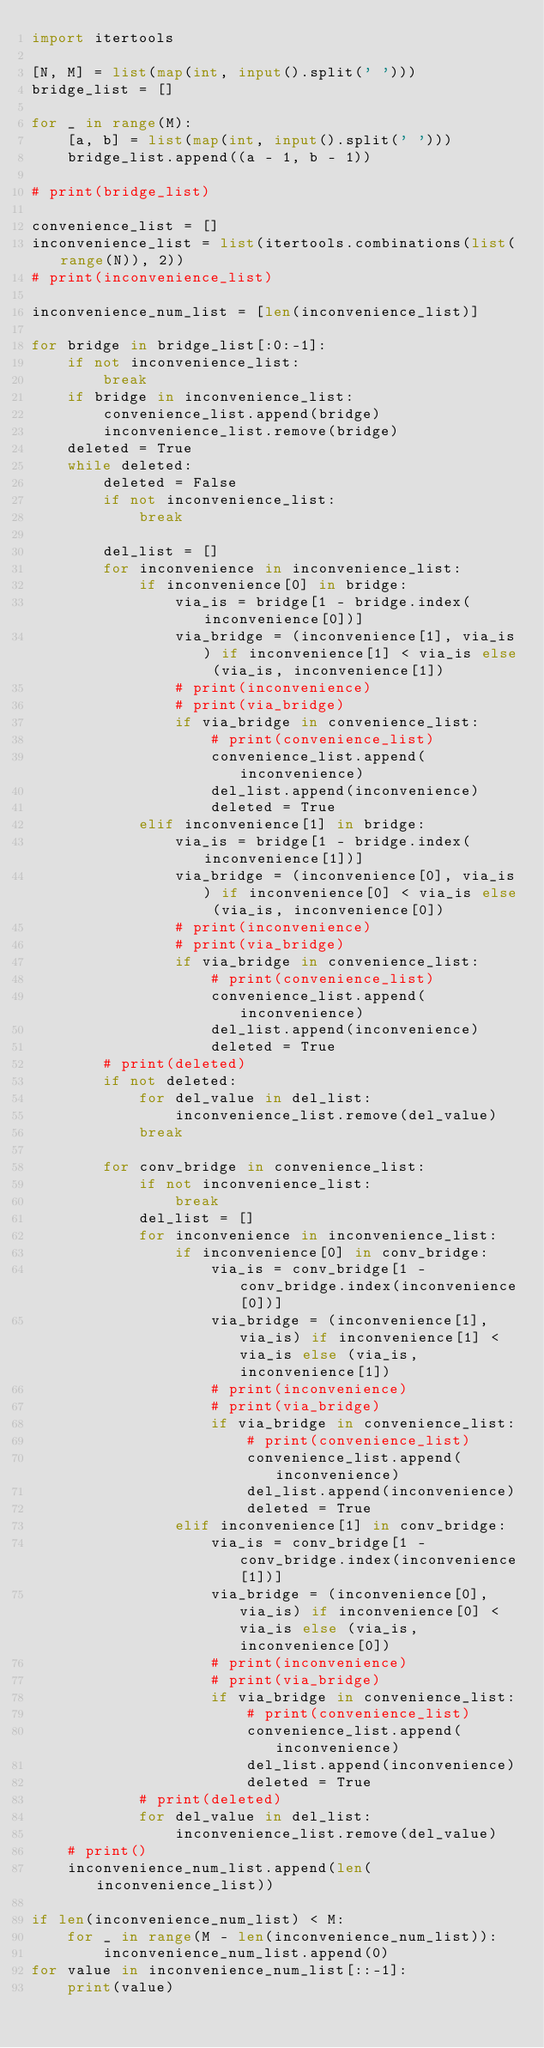<code> <loc_0><loc_0><loc_500><loc_500><_Python_>import itertools

[N, M] = list(map(int, input().split(' ')))
bridge_list = []

for _ in range(M):
    [a, b] = list(map(int, input().split(' ')))
    bridge_list.append((a - 1, b - 1))

# print(bridge_list)

convenience_list = []
inconvenience_list = list(itertools.combinations(list(range(N)), 2))
# print(inconvenience_list)

inconvenience_num_list = [len(inconvenience_list)]

for bridge in bridge_list[:0:-1]:
    if not inconvenience_list:
        break
    if bridge in inconvenience_list:
        convenience_list.append(bridge)
        inconvenience_list.remove(bridge)
    deleted = True
    while deleted:
        deleted = False
        if not inconvenience_list:
            break

        del_list = []
        for inconvenience in inconvenience_list:
            if inconvenience[0] in bridge:
                via_is = bridge[1 - bridge.index(inconvenience[0])]
                via_bridge = (inconvenience[1], via_is) if inconvenience[1] < via_is else (via_is, inconvenience[1])
                # print(inconvenience)
                # print(via_bridge)
                if via_bridge in convenience_list:
                    # print(convenience_list)
                    convenience_list.append(inconvenience)
                    del_list.append(inconvenience)
                    deleted = True
            elif inconvenience[1] in bridge:
                via_is = bridge[1 - bridge.index(inconvenience[1])]
                via_bridge = (inconvenience[0], via_is) if inconvenience[0] < via_is else (via_is, inconvenience[0])
                # print(inconvenience)
                # print(via_bridge)
                if via_bridge in convenience_list:
                    # print(convenience_list)
                    convenience_list.append(inconvenience)
                    del_list.append(inconvenience)
                    deleted = True
        # print(deleted)
        if not deleted:
            for del_value in del_list:
                inconvenience_list.remove(del_value)
            break
        
        for conv_bridge in convenience_list:
            if not inconvenience_list:
                break
            del_list = []
            for inconvenience in inconvenience_list:
                if inconvenience[0] in conv_bridge:
                    via_is = conv_bridge[1 - conv_bridge.index(inconvenience[0])]
                    via_bridge = (inconvenience[1], via_is) if inconvenience[1] < via_is else (via_is, inconvenience[1])
                    # print(inconvenience)
                    # print(via_bridge)
                    if via_bridge in convenience_list:
                        # print(convenience_list)
                        convenience_list.append(inconvenience)
                        del_list.append(inconvenience)
                        deleted = True
                elif inconvenience[1] in conv_bridge:
                    via_is = conv_bridge[1 - conv_bridge.index(inconvenience[1])]
                    via_bridge = (inconvenience[0], via_is) if inconvenience[0] < via_is else (via_is, inconvenience[0])
                    # print(inconvenience)
                    # print(via_bridge)
                    if via_bridge in convenience_list:
                        # print(convenience_list)
                        convenience_list.append(inconvenience)
                        del_list.append(inconvenience)
                        deleted = True
            # print(deleted)
            for del_value in del_list:
                inconvenience_list.remove(del_value)
    # print()
    inconvenience_num_list.append(len(inconvenience_list))

if len(inconvenience_num_list) < M:
    for _ in range(M - len(inconvenience_num_list)):
        inconvenience_num_list.append(0)
for value in inconvenience_num_list[::-1]:
    print(value)
</code> 